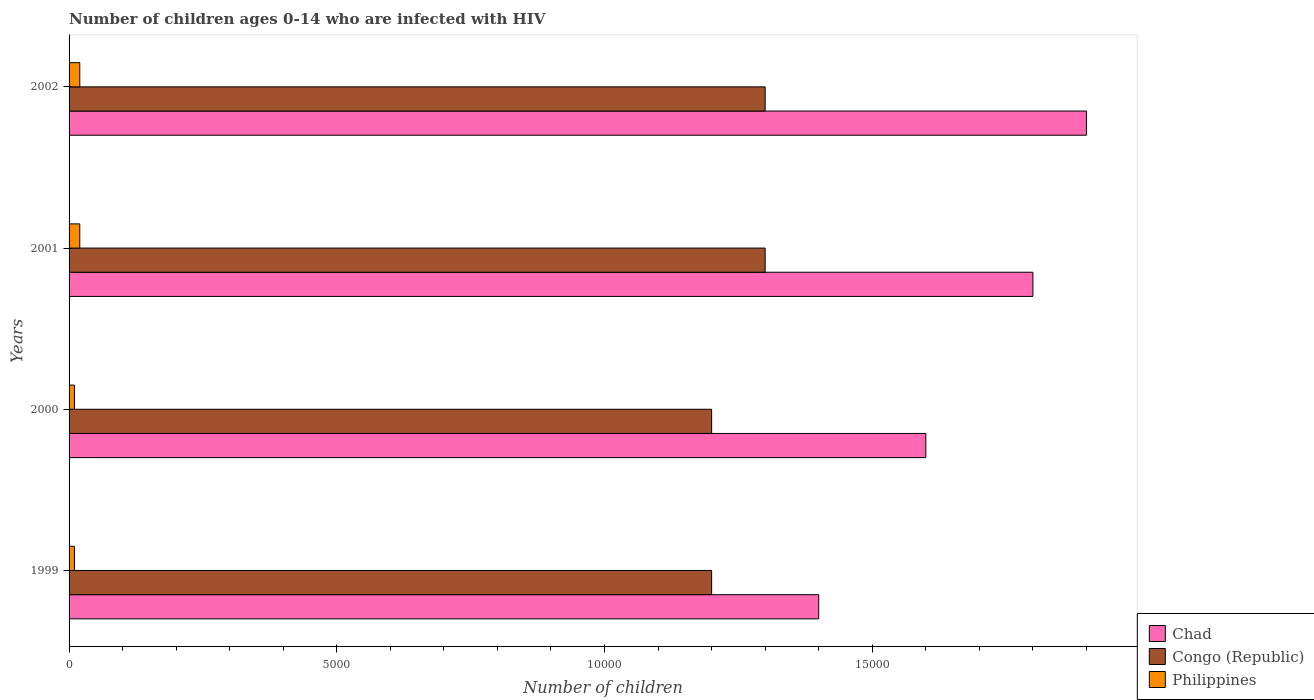How many groups of bars are there?
Keep it short and to the point. 4. Are the number of bars per tick equal to the number of legend labels?
Your answer should be very brief. Yes. How many bars are there on the 1st tick from the top?
Offer a terse response. 3. What is the label of the 1st group of bars from the top?
Ensure brevity in your answer.  2002. What is the number of HIV infected children in Chad in 1999?
Keep it short and to the point. 1.40e+04. Across all years, what is the maximum number of HIV infected children in Philippines?
Keep it short and to the point. 200. Across all years, what is the minimum number of HIV infected children in Congo (Republic)?
Give a very brief answer. 1.20e+04. What is the total number of HIV infected children in Congo (Republic) in the graph?
Your response must be concise. 5.00e+04. What is the difference between the number of HIV infected children in Chad in 2001 and that in 2002?
Your answer should be compact. -1000. What is the difference between the number of HIV infected children in Chad in 2000 and the number of HIV infected children in Philippines in 2002?
Your response must be concise. 1.58e+04. What is the average number of HIV infected children in Philippines per year?
Keep it short and to the point. 150. In the year 2000, what is the difference between the number of HIV infected children in Chad and number of HIV infected children in Congo (Republic)?
Offer a very short reply. 4000. In how many years, is the number of HIV infected children in Chad greater than 17000 ?
Your answer should be very brief. 2. What is the ratio of the number of HIV infected children in Congo (Republic) in 1999 to that in 2002?
Your response must be concise. 0.92. Is the difference between the number of HIV infected children in Chad in 2000 and 2002 greater than the difference between the number of HIV infected children in Congo (Republic) in 2000 and 2002?
Your answer should be very brief. No. What is the difference between the highest and the lowest number of HIV infected children in Chad?
Give a very brief answer. 5000. What does the 1st bar from the top in 1999 represents?
Provide a succinct answer. Philippines. What does the 1st bar from the bottom in 1999 represents?
Your answer should be compact. Chad. Is it the case that in every year, the sum of the number of HIV infected children in Congo (Republic) and number of HIV infected children in Philippines is greater than the number of HIV infected children in Chad?
Your answer should be very brief. No. Are all the bars in the graph horizontal?
Make the answer very short. Yes. What is the difference between two consecutive major ticks on the X-axis?
Ensure brevity in your answer.  5000. Does the graph contain any zero values?
Make the answer very short. No. Where does the legend appear in the graph?
Offer a terse response. Bottom right. How are the legend labels stacked?
Offer a very short reply. Vertical. What is the title of the graph?
Give a very brief answer. Number of children ages 0-14 who are infected with HIV. What is the label or title of the X-axis?
Provide a short and direct response. Number of children. What is the label or title of the Y-axis?
Give a very brief answer. Years. What is the Number of children of Chad in 1999?
Give a very brief answer. 1.40e+04. What is the Number of children of Congo (Republic) in 1999?
Your answer should be very brief. 1.20e+04. What is the Number of children in Chad in 2000?
Your response must be concise. 1.60e+04. What is the Number of children in Congo (Republic) in 2000?
Make the answer very short. 1.20e+04. What is the Number of children in Chad in 2001?
Offer a terse response. 1.80e+04. What is the Number of children of Congo (Republic) in 2001?
Give a very brief answer. 1.30e+04. What is the Number of children in Chad in 2002?
Your response must be concise. 1.90e+04. What is the Number of children of Congo (Republic) in 2002?
Offer a very short reply. 1.30e+04. Across all years, what is the maximum Number of children of Chad?
Give a very brief answer. 1.90e+04. Across all years, what is the maximum Number of children in Congo (Republic)?
Offer a very short reply. 1.30e+04. Across all years, what is the minimum Number of children in Chad?
Offer a terse response. 1.40e+04. Across all years, what is the minimum Number of children in Congo (Republic)?
Give a very brief answer. 1.20e+04. What is the total Number of children in Chad in the graph?
Make the answer very short. 6.70e+04. What is the total Number of children in Congo (Republic) in the graph?
Your response must be concise. 5.00e+04. What is the total Number of children in Philippines in the graph?
Give a very brief answer. 600. What is the difference between the Number of children in Chad in 1999 and that in 2000?
Offer a terse response. -2000. What is the difference between the Number of children of Congo (Republic) in 1999 and that in 2000?
Offer a very short reply. 0. What is the difference between the Number of children of Chad in 1999 and that in 2001?
Your response must be concise. -4000. What is the difference between the Number of children in Congo (Republic) in 1999 and that in 2001?
Make the answer very short. -1000. What is the difference between the Number of children in Philippines in 1999 and that in 2001?
Your response must be concise. -100. What is the difference between the Number of children of Chad in 1999 and that in 2002?
Provide a succinct answer. -5000. What is the difference between the Number of children of Congo (Republic) in 1999 and that in 2002?
Provide a short and direct response. -1000. What is the difference between the Number of children of Philippines in 1999 and that in 2002?
Provide a succinct answer. -100. What is the difference between the Number of children of Chad in 2000 and that in 2001?
Keep it short and to the point. -2000. What is the difference between the Number of children in Congo (Republic) in 2000 and that in 2001?
Ensure brevity in your answer.  -1000. What is the difference between the Number of children in Philippines in 2000 and that in 2001?
Offer a very short reply. -100. What is the difference between the Number of children of Chad in 2000 and that in 2002?
Provide a short and direct response. -3000. What is the difference between the Number of children of Congo (Republic) in 2000 and that in 2002?
Keep it short and to the point. -1000. What is the difference between the Number of children of Philippines in 2000 and that in 2002?
Offer a terse response. -100. What is the difference between the Number of children of Chad in 2001 and that in 2002?
Offer a very short reply. -1000. What is the difference between the Number of children of Congo (Republic) in 2001 and that in 2002?
Your answer should be very brief. 0. What is the difference between the Number of children of Philippines in 2001 and that in 2002?
Offer a very short reply. 0. What is the difference between the Number of children of Chad in 1999 and the Number of children of Congo (Republic) in 2000?
Ensure brevity in your answer.  2000. What is the difference between the Number of children of Chad in 1999 and the Number of children of Philippines in 2000?
Keep it short and to the point. 1.39e+04. What is the difference between the Number of children in Congo (Republic) in 1999 and the Number of children in Philippines in 2000?
Make the answer very short. 1.19e+04. What is the difference between the Number of children of Chad in 1999 and the Number of children of Congo (Republic) in 2001?
Provide a succinct answer. 1000. What is the difference between the Number of children of Chad in 1999 and the Number of children of Philippines in 2001?
Give a very brief answer. 1.38e+04. What is the difference between the Number of children of Congo (Republic) in 1999 and the Number of children of Philippines in 2001?
Offer a very short reply. 1.18e+04. What is the difference between the Number of children of Chad in 1999 and the Number of children of Philippines in 2002?
Ensure brevity in your answer.  1.38e+04. What is the difference between the Number of children in Congo (Republic) in 1999 and the Number of children in Philippines in 2002?
Give a very brief answer. 1.18e+04. What is the difference between the Number of children in Chad in 2000 and the Number of children in Congo (Republic) in 2001?
Keep it short and to the point. 3000. What is the difference between the Number of children of Chad in 2000 and the Number of children of Philippines in 2001?
Offer a terse response. 1.58e+04. What is the difference between the Number of children of Congo (Republic) in 2000 and the Number of children of Philippines in 2001?
Offer a very short reply. 1.18e+04. What is the difference between the Number of children of Chad in 2000 and the Number of children of Congo (Republic) in 2002?
Give a very brief answer. 3000. What is the difference between the Number of children in Chad in 2000 and the Number of children in Philippines in 2002?
Offer a terse response. 1.58e+04. What is the difference between the Number of children in Congo (Republic) in 2000 and the Number of children in Philippines in 2002?
Your answer should be compact. 1.18e+04. What is the difference between the Number of children in Chad in 2001 and the Number of children in Congo (Republic) in 2002?
Provide a short and direct response. 5000. What is the difference between the Number of children in Chad in 2001 and the Number of children in Philippines in 2002?
Your response must be concise. 1.78e+04. What is the difference between the Number of children of Congo (Republic) in 2001 and the Number of children of Philippines in 2002?
Your response must be concise. 1.28e+04. What is the average Number of children of Chad per year?
Offer a very short reply. 1.68e+04. What is the average Number of children in Congo (Republic) per year?
Provide a succinct answer. 1.25e+04. What is the average Number of children of Philippines per year?
Offer a terse response. 150. In the year 1999, what is the difference between the Number of children in Chad and Number of children in Congo (Republic)?
Your response must be concise. 2000. In the year 1999, what is the difference between the Number of children in Chad and Number of children in Philippines?
Provide a short and direct response. 1.39e+04. In the year 1999, what is the difference between the Number of children of Congo (Republic) and Number of children of Philippines?
Give a very brief answer. 1.19e+04. In the year 2000, what is the difference between the Number of children of Chad and Number of children of Congo (Republic)?
Make the answer very short. 4000. In the year 2000, what is the difference between the Number of children in Chad and Number of children in Philippines?
Give a very brief answer. 1.59e+04. In the year 2000, what is the difference between the Number of children of Congo (Republic) and Number of children of Philippines?
Give a very brief answer. 1.19e+04. In the year 2001, what is the difference between the Number of children of Chad and Number of children of Philippines?
Keep it short and to the point. 1.78e+04. In the year 2001, what is the difference between the Number of children in Congo (Republic) and Number of children in Philippines?
Provide a short and direct response. 1.28e+04. In the year 2002, what is the difference between the Number of children in Chad and Number of children in Congo (Republic)?
Your answer should be compact. 6000. In the year 2002, what is the difference between the Number of children of Chad and Number of children of Philippines?
Provide a succinct answer. 1.88e+04. In the year 2002, what is the difference between the Number of children in Congo (Republic) and Number of children in Philippines?
Keep it short and to the point. 1.28e+04. What is the ratio of the Number of children of Congo (Republic) in 1999 to that in 2000?
Keep it short and to the point. 1. What is the ratio of the Number of children in Congo (Republic) in 1999 to that in 2001?
Provide a succinct answer. 0.92. What is the ratio of the Number of children in Philippines in 1999 to that in 2001?
Provide a succinct answer. 0.5. What is the ratio of the Number of children of Chad in 1999 to that in 2002?
Offer a very short reply. 0.74. What is the ratio of the Number of children in Congo (Republic) in 1999 to that in 2002?
Offer a terse response. 0.92. What is the ratio of the Number of children in Philippines in 1999 to that in 2002?
Provide a succinct answer. 0.5. What is the ratio of the Number of children of Chad in 2000 to that in 2001?
Ensure brevity in your answer.  0.89. What is the ratio of the Number of children of Congo (Republic) in 2000 to that in 2001?
Your answer should be very brief. 0.92. What is the ratio of the Number of children in Chad in 2000 to that in 2002?
Offer a terse response. 0.84. What is the ratio of the Number of children in Chad in 2001 to that in 2002?
Provide a short and direct response. 0.95. What is the difference between the highest and the second highest Number of children in Congo (Republic)?
Ensure brevity in your answer.  0. What is the difference between the highest and the second highest Number of children of Philippines?
Offer a terse response. 0. What is the difference between the highest and the lowest Number of children of Congo (Republic)?
Offer a very short reply. 1000. What is the difference between the highest and the lowest Number of children in Philippines?
Your answer should be compact. 100. 